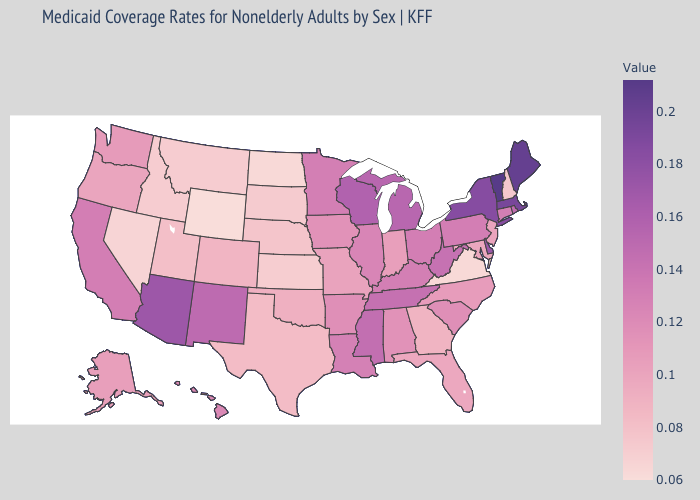Does Massachusetts have the highest value in the Northeast?
Be succinct. No. Which states have the lowest value in the South?
Be succinct. Virginia. Among the states that border New Mexico , does Arizona have the lowest value?
Concise answer only. No. Does Vermont have the highest value in the Northeast?
Keep it brief. Yes. Does Utah have the lowest value in the West?
Write a very short answer. No. Does the map have missing data?
Be succinct. No. Does the map have missing data?
Keep it brief. No. Does the map have missing data?
Keep it brief. No. 